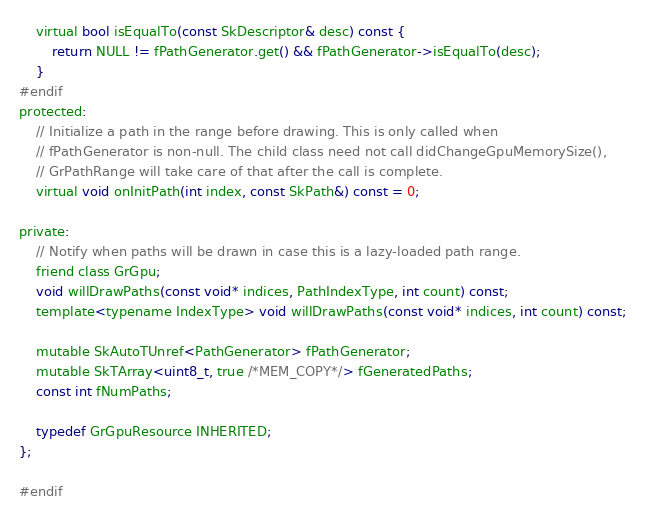<code> <loc_0><loc_0><loc_500><loc_500><_C_>    virtual bool isEqualTo(const SkDescriptor& desc) const {
        return NULL != fPathGenerator.get() && fPathGenerator->isEqualTo(desc);
    }
#endif
protected:
    // Initialize a path in the range before drawing. This is only called when
    // fPathGenerator is non-null. The child class need not call didChangeGpuMemorySize(),
    // GrPathRange will take care of that after the call is complete.
    virtual void onInitPath(int index, const SkPath&) const = 0;

private:
    // Notify when paths will be drawn in case this is a lazy-loaded path range.
    friend class GrGpu;
    void willDrawPaths(const void* indices, PathIndexType, int count) const;
    template<typename IndexType> void willDrawPaths(const void* indices, int count) const;

    mutable SkAutoTUnref<PathGenerator> fPathGenerator;
    mutable SkTArray<uint8_t, true /*MEM_COPY*/> fGeneratedPaths;
    const int fNumPaths;

    typedef GrGpuResource INHERITED;
};

#endif
</code> 